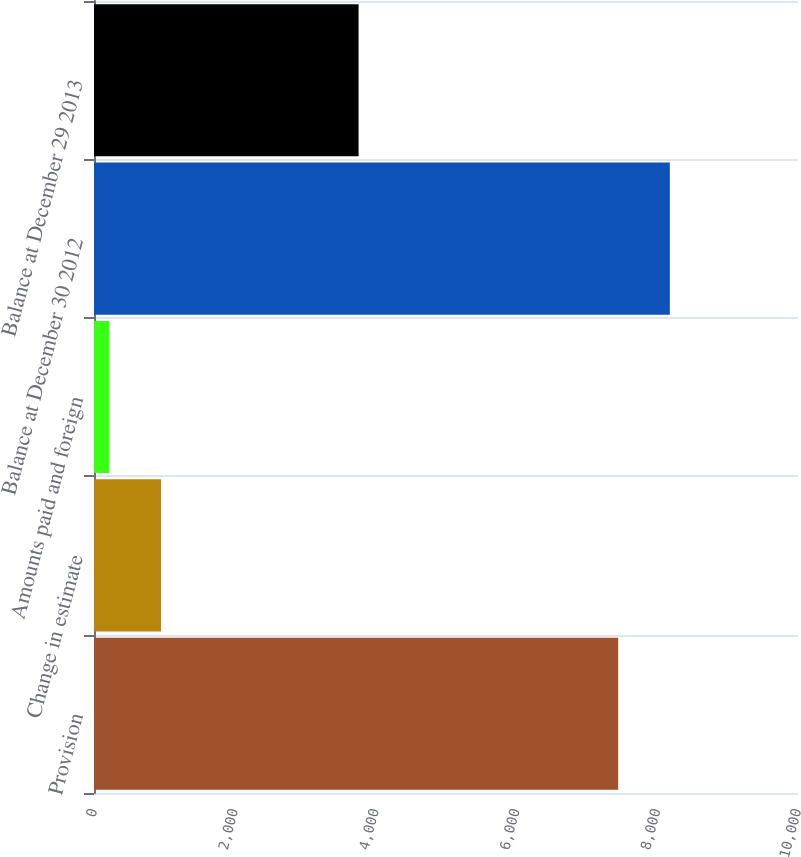Convert chart. <chart><loc_0><loc_0><loc_500><loc_500><bar_chart><fcel>Provision<fcel>Change in estimate<fcel>Amounts paid and foreign<fcel>Balance at December 30 2012<fcel>Balance at December 29 2013<nl><fcel>7446<fcel>952.4<fcel>219<fcel>8179.4<fcel>3758<nl></chart> 